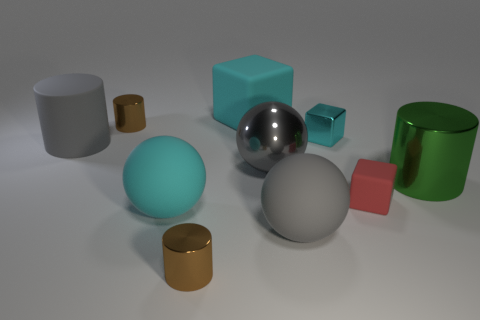Are the large green thing and the small cyan object made of the same material?
Ensure brevity in your answer.  Yes. What number of big objects are the same material as the cyan sphere?
Provide a succinct answer. 3. What number of objects are either brown cylinders that are behind the cyan metal cube or large green metallic things in front of the small cyan cube?
Give a very brief answer. 2. Are there more rubber balls in front of the big green metal cylinder than big spheres that are behind the small cyan cube?
Offer a very short reply. Yes. There is a cylinder that is to the right of the big cyan rubber block; what is its color?
Make the answer very short. Green. Are there any shiny objects that have the same shape as the red rubber thing?
Provide a short and direct response. Yes. How many brown objects are shiny cubes or small metal things?
Give a very brief answer. 2. Is there a cyan object that has the same size as the red object?
Give a very brief answer. Yes. What number of tiny cyan shiny blocks are there?
Your response must be concise. 1. How many tiny things are either blocks or metallic objects?
Offer a terse response. 4. 